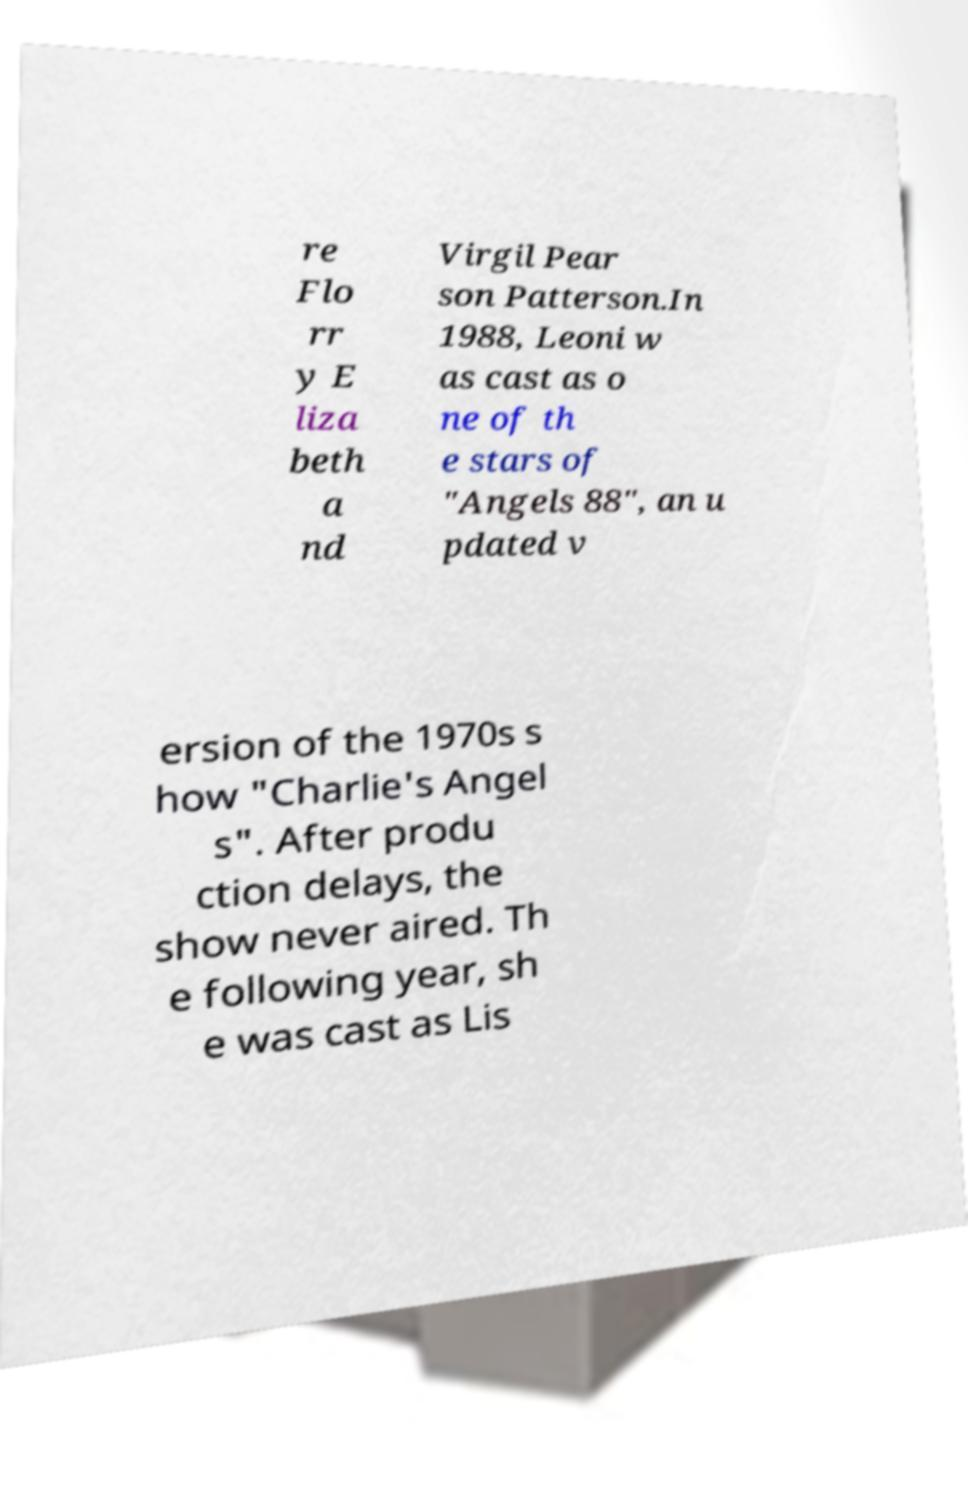I need the written content from this picture converted into text. Can you do that? re Flo rr y E liza beth a nd Virgil Pear son Patterson.In 1988, Leoni w as cast as o ne of th e stars of "Angels 88", an u pdated v ersion of the 1970s s how "Charlie's Angel s". After produ ction delays, the show never aired. Th e following year, sh e was cast as Lis 